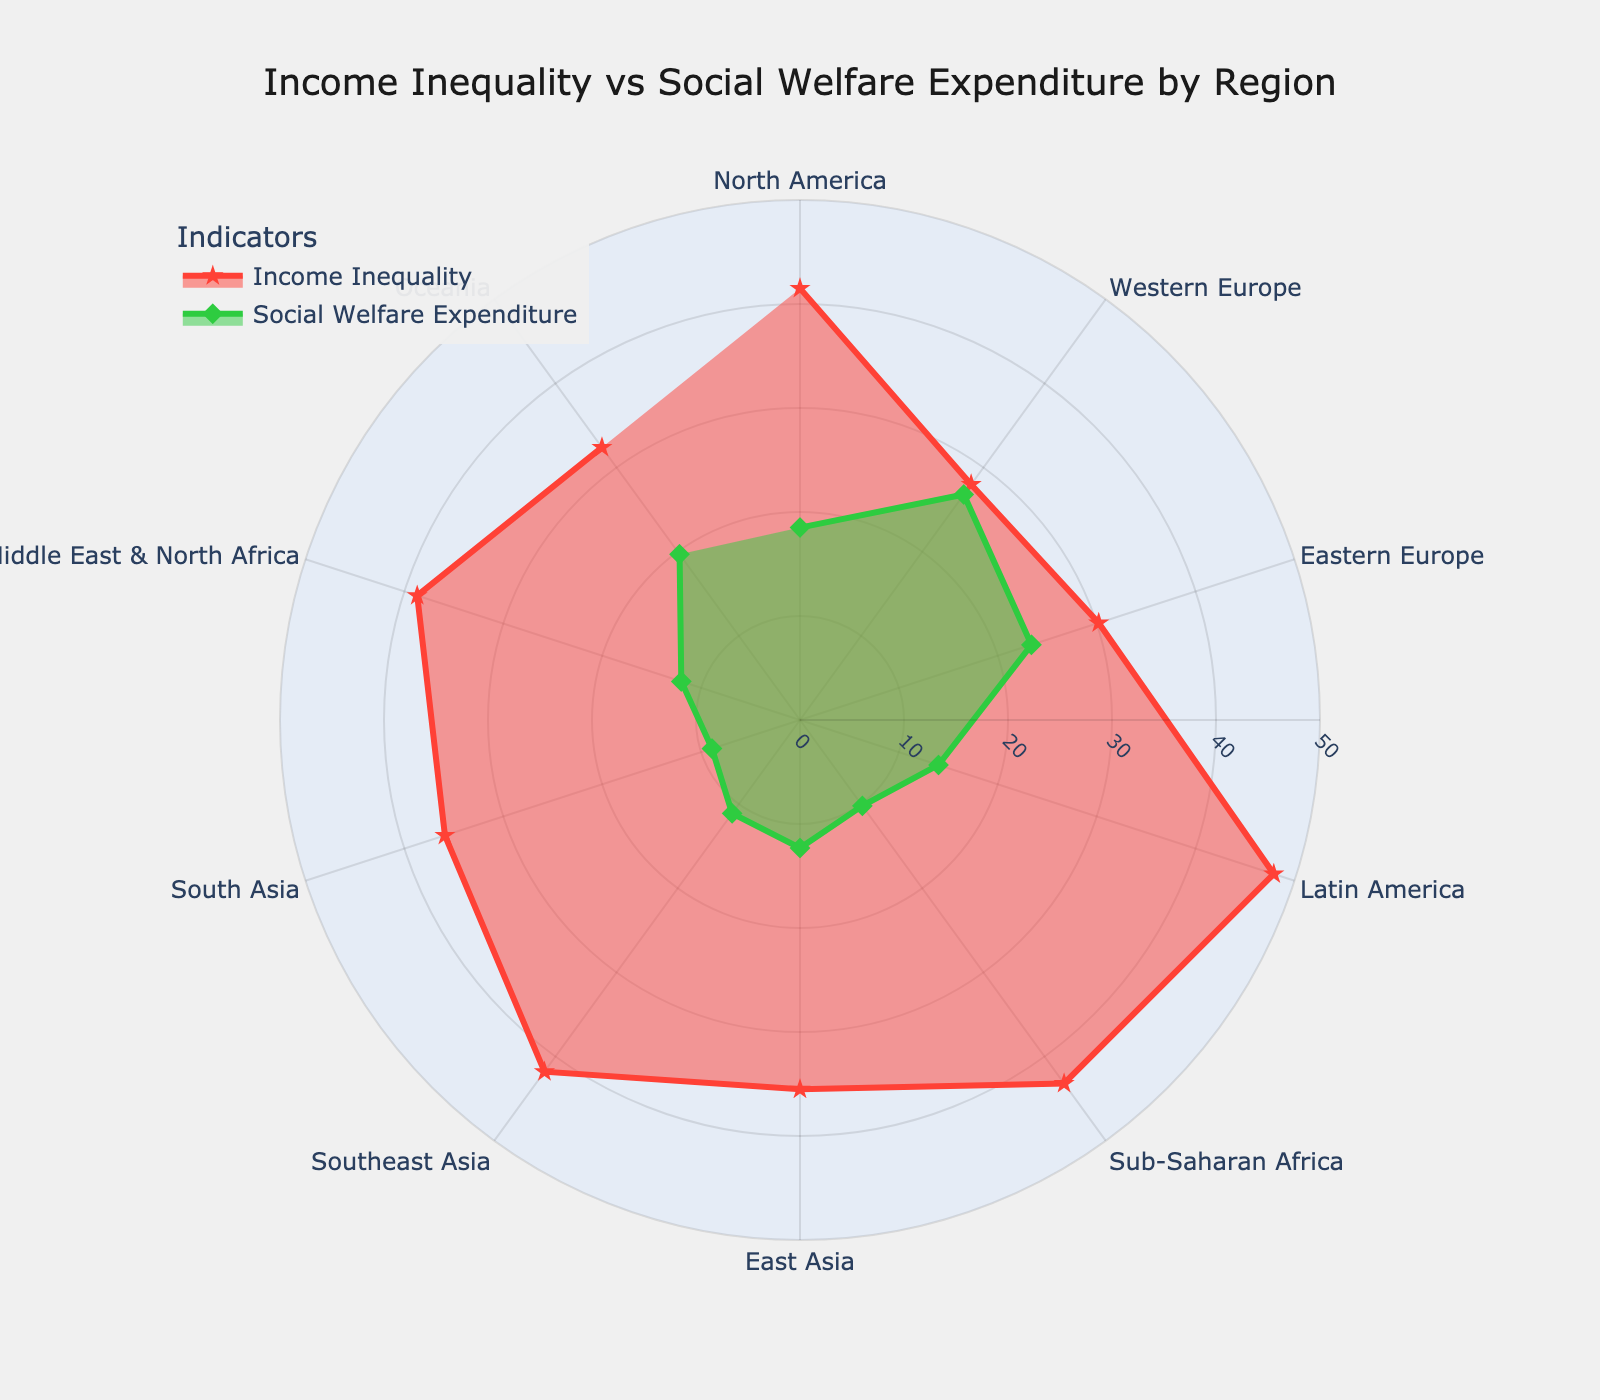Which region has the highest income inequality? By looking at the red line (Income Inequality) on the radar chart, we can see that Latin America has the highest Gini Index.
Answer: Latin America Which region has the lowest social welfare expenditure? By examining the green line (Social Welfare Expenditure) on the radar chart, South Asia has the lowest percentage of GDP allocated to social welfare.
Answer: South Asia How does income inequality in North America compare to that in Western Europe? North America's Gini Index (red line point) is visibly higher compared to Western Europe's Gini Index.
Answer: Higher What is the difference in social welfare expenditure between Western Europe and North America? Western Europe's social welfare expenditure is 26.8% of GDP, and North America's is 18.5%. The difference is calculated as 26.8 - 18.5.
Answer: 8.3% Which regions have similar income inequality levels (within 1 unit of each other)? By observing the red line points close to each other, Eastern Europe and Oceania (30.2 and 32.4), as well as South Asia and East Asia (35.9 and 35.5) have similar Gini Index values.
Answer: Eastern Europe & Oceania, South Asia & East Asia What is the average social welfare expenditure for regions with a Gini Index above 40? The regions with Gini Index above 40 are North America (18.5%), Latin America (14.0%), Sub-Saharan Africa (10.2%), and Southeast Asia (11.1%). Sum these values and divide by 4 for the average. (18.5 + 14.0 + 10.2 + 11.1) / 4 = 13.45.
Answer: 13.45% Compare the income inequality and social welfare expenditure in Sub-Saharan Africa and East Asia. Sub-Saharan Africa's Gini Index is higher (43.2 vs 35.5) and their social welfare expenditure is lower (10.2% vs 12.3%) compared to East Asia.
Answer: Higher inequality, lower expenditure Are there any regions where income inequality and social welfare expenditure are both relatively low? Looking at both the red and green lines, South Asia shows low levels in both income inequality and social welfare expenditure, with a Gini Index of 35.9 and social expenditure of 8.9%.
Answer: South Asia Is there a correlation between high social welfare expenditure and low income inequality? By comparing green and red lines across regions, Western Europe shows high social welfare expenditure with low income inequality, suggesting an inverse relationship.
Answer: Yes, inverse What percentage of GDP is spent on social welfare in Oceania? Checking the green line point for Oceania, it indicates that 19.7% of GDP is spent on social welfare.
Answer: 19.7% 